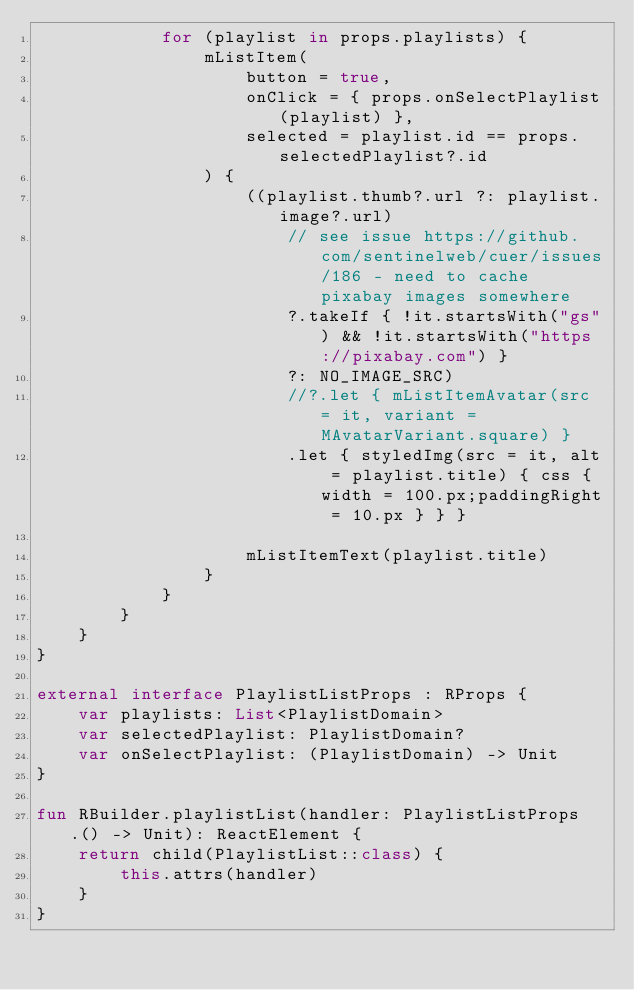Convert code to text. <code><loc_0><loc_0><loc_500><loc_500><_Kotlin_>            for (playlist in props.playlists) {
                mListItem(
                    button = true,
                    onClick = { props.onSelectPlaylist(playlist) },
                    selected = playlist.id == props.selectedPlaylist?.id
                ) {
                    ((playlist.thumb?.url ?: playlist.image?.url)
                        // see issue https://github.com/sentinelweb/cuer/issues/186 - need to cache pixabay images somewhere
                        ?.takeIf { !it.startsWith("gs") && !it.startsWith("https://pixabay.com") }
                        ?: NO_IMAGE_SRC)
                        //?.let { mListItemAvatar(src = it, variant = MAvatarVariant.square) }
                        .let { styledImg(src = it, alt = playlist.title) { css { width = 100.px;paddingRight = 10.px } } }

                    mListItemText(playlist.title)
                }
            }
        }
    }
}

external interface PlaylistListProps : RProps {
    var playlists: List<PlaylistDomain>
    var selectedPlaylist: PlaylistDomain?
    var onSelectPlaylist: (PlaylistDomain) -> Unit
}

fun RBuilder.playlistList(handler: PlaylistListProps.() -> Unit): ReactElement {
    return child(PlaylistList::class) {
        this.attrs(handler)
    }
}
</code> 